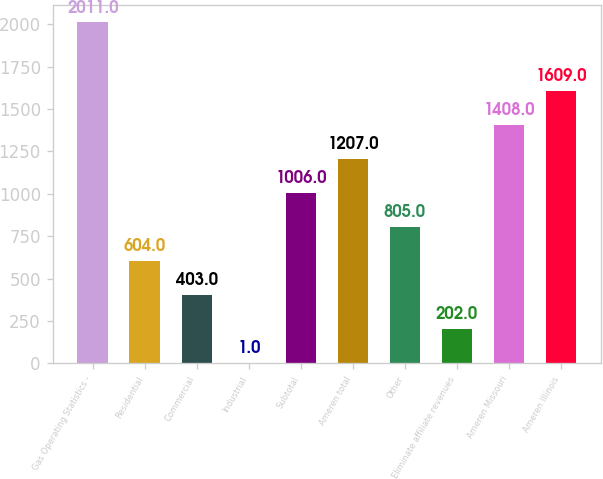<chart> <loc_0><loc_0><loc_500><loc_500><bar_chart><fcel>Gas Operating Statistics -<fcel>Residential<fcel>Commercial<fcel>Industrial<fcel>Subtotal<fcel>Ameren total<fcel>Other<fcel>Eliminate affiliate revenues<fcel>Ameren Missouri<fcel>Ameren Illinois<nl><fcel>2011<fcel>604<fcel>403<fcel>1<fcel>1006<fcel>1207<fcel>805<fcel>202<fcel>1408<fcel>1609<nl></chart> 